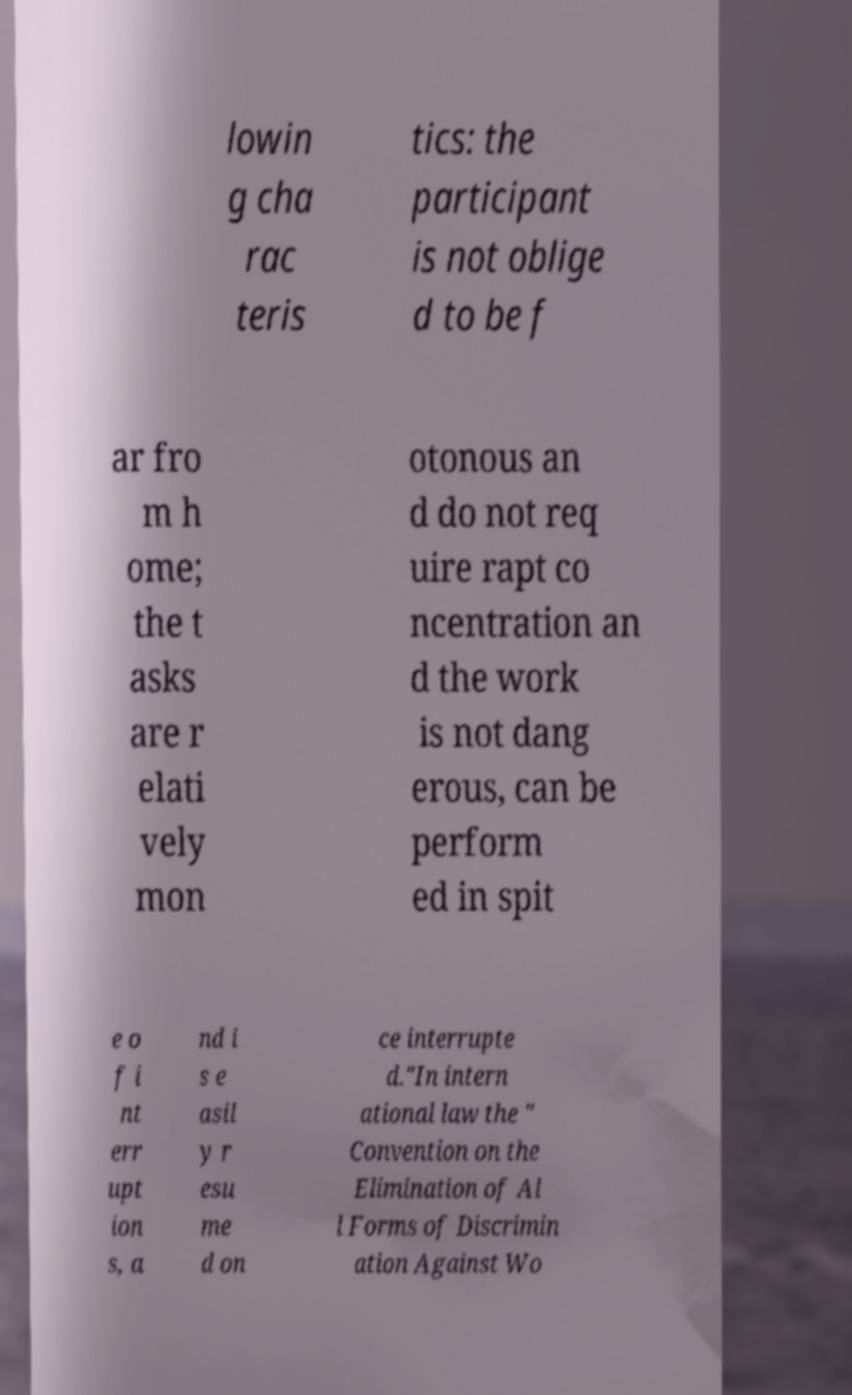Please identify and transcribe the text found in this image. lowin g cha rac teris tics: the participant is not oblige d to be f ar fro m h ome; the t asks are r elati vely mon otonous an d do not req uire rapt co ncentration an d the work is not dang erous, can be perform ed in spit e o f i nt err upt ion s, a nd i s e asil y r esu me d on ce interrupte d."In intern ational law the " Convention on the Elimination of Al l Forms of Discrimin ation Against Wo 